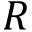<formula> <loc_0><loc_0><loc_500><loc_500>R</formula> 